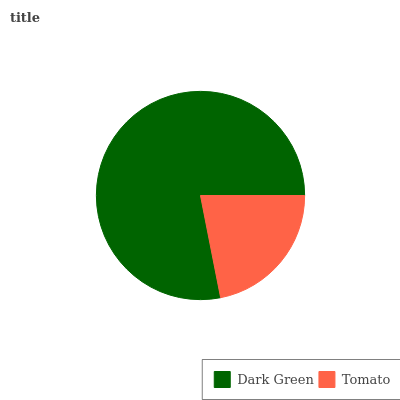Is Tomato the minimum?
Answer yes or no. Yes. Is Dark Green the maximum?
Answer yes or no. Yes. Is Tomato the maximum?
Answer yes or no. No. Is Dark Green greater than Tomato?
Answer yes or no. Yes. Is Tomato less than Dark Green?
Answer yes or no. Yes. Is Tomato greater than Dark Green?
Answer yes or no. No. Is Dark Green less than Tomato?
Answer yes or no. No. Is Dark Green the high median?
Answer yes or no. Yes. Is Tomato the low median?
Answer yes or no. Yes. Is Tomato the high median?
Answer yes or no. No. Is Dark Green the low median?
Answer yes or no. No. 